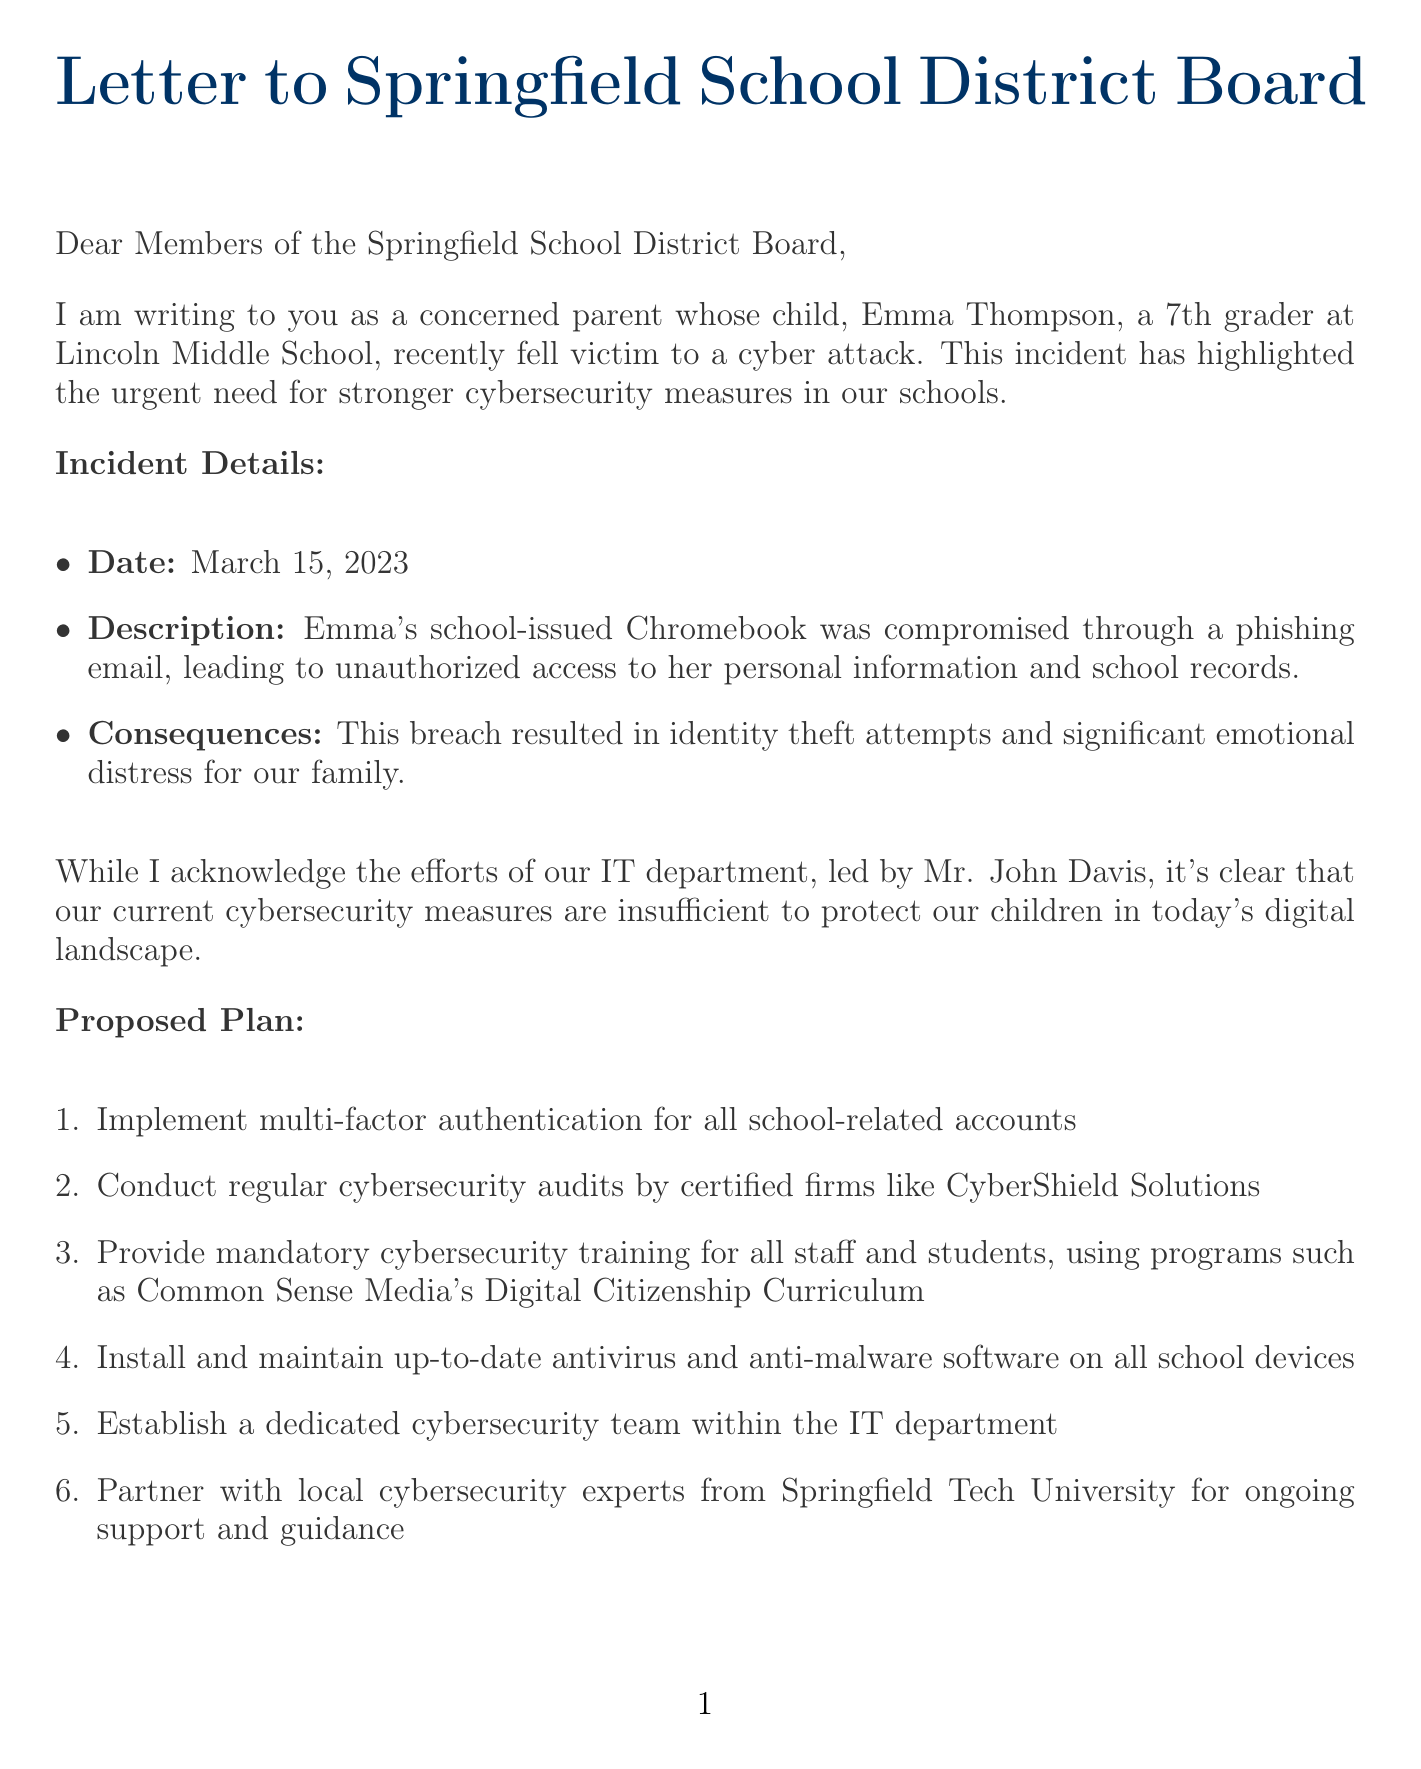what is the name of the child affected by the cyber attack? The name of the child mentioned in the letter is Emma Thompson.
Answer: Emma Thompson what date did the cyber attack occur? The letter specifies that the cyber attack happened on March 15, 2023.
Answer: March 15, 2023 who leads the IT department as mentioned in the letter? The letter indicates Mr. John Davis is the head of the IT department.
Answer: Mr. John Davis how much of the annual technology budget is proposed for cybersecurity initiatives? The proposed allocation for cybersecurity initiatives is 5% of the district's annual technology budget.
Answer: 5% what is the average cost of a data breach in the education sector? The document reports that the average cost of a data breach in education is $3.79 million.
Answer: $3.79 million what is the name of the parent group started to raise cybersecurity awareness? The letter mentions a parent group called 'Digital Guardians'.
Answer: 'Digital Guardians' what was one of the consequences of the cyber attack mentioned in the document? The letter states that one consequence was identity theft attempts.
Answer: identity theft attempts what expert organization does Dr. Maria Chen belong to? Dr. Maria Chen is associated with the International Society for Technology in Education.
Answer: International Society for Technology in Education what action does the author urge the school board to take? The author urges the board to take immediate action to protect children's digital safety.
Answer: immediate action to protect our children's digital safety 